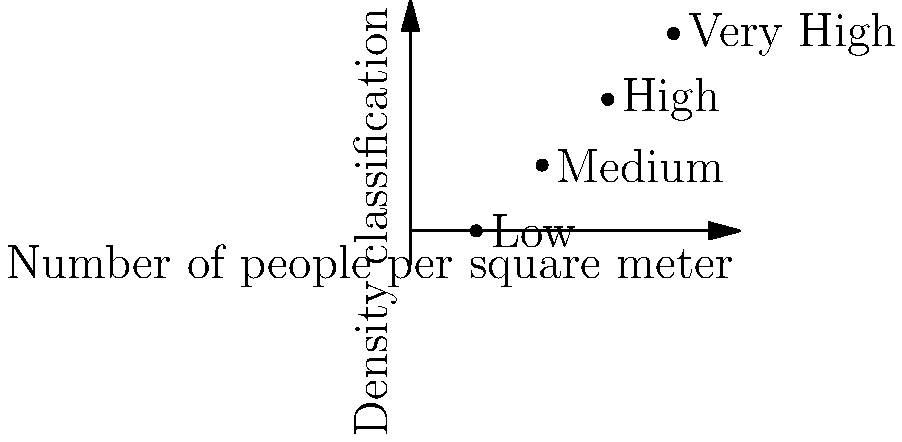As a tourism manager in Liechtenstein, you're tasked with estimating crowd sizes at various events using aerial photographs. Based on the graph showing density classifications, what would be the estimated number of people in a 500 square meter area if the crowd density is classified as "High"? To solve this problem, we'll follow these steps:

1. Identify the density classification: The question states the crowd density is classified as "High".

2. Determine the corresponding number of people per square meter:
   From the graph, we can see that "High" corresponds to 3 people per square meter.

3. Calculate the total area given:
   The area is given as 500 square meters.

4. Apply the formula to estimate the number of people:
   Number of people = People per square meter × Total area
   
   $$ \text{Number of people} = 3 \text{ people/m}^2 \times 500 \text{ m}^2 $$

5. Perform the calculation:
   $$ \text{Number of people} = 3 \times 500 = 1500 $$

Therefore, the estimated number of people in a 500 square meter area with a "High" crowd density is 1500 people.
Answer: 1500 people 